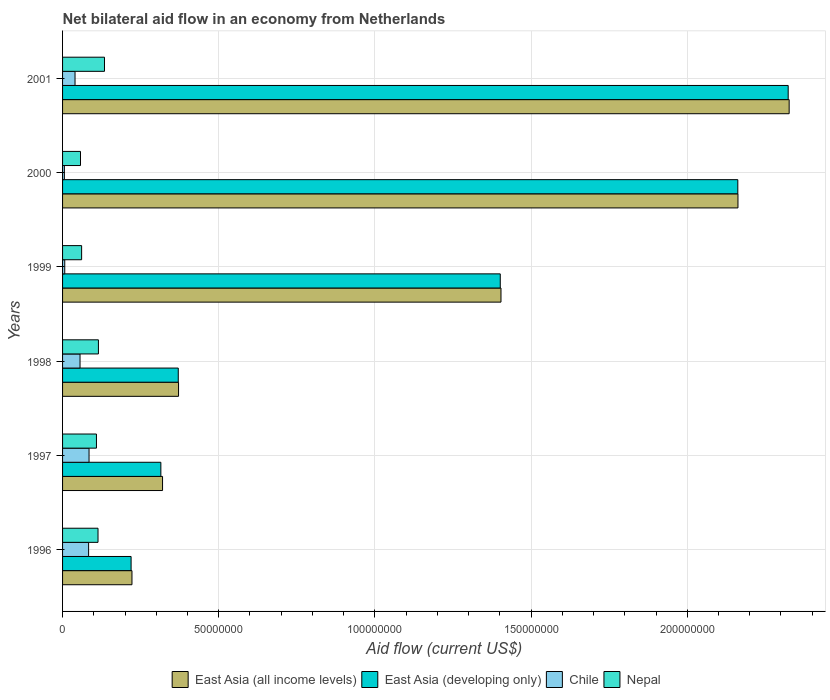How many different coloured bars are there?
Keep it short and to the point. 4. How many groups of bars are there?
Make the answer very short. 6. Are the number of bars per tick equal to the number of legend labels?
Make the answer very short. Yes. How many bars are there on the 3rd tick from the top?
Your response must be concise. 4. What is the label of the 3rd group of bars from the top?
Keep it short and to the point. 1999. What is the net bilateral aid flow in Nepal in 1999?
Provide a short and direct response. 6.10e+06. Across all years, what is the maximum net bilateral aid flow in East Asia (developing only)?
Make the answer very short. 2.32e+08. Across all years, what is the minimum net bilateral aid flow in Chile?
Provide a succinct answer. 5.80e+05. In which year was the net bilateral aid flow in East Asia (developing only) minimum?
Offer a very short reply. 1996. What is the total net bilateral aid flow in East Asia (all income levels) in the graph?
Your response must be concise. 6.81e+08. What is the difference between the net bilateral aid flow in East Asia (all income levels) in 1998 and that in 2001?
Your answer should be compact. -1.95e+08. What is the difference between the net bilateral aid flow in East Asia (all income levels) in 1997 and the net bilateral aid flow in Nepal in 1999?
Keep it short and to the point. 2.59e+07. What is the average net bilateral aid flow in Nepal per year?
Make the answer very short. 9.82e+06. In the year 2001, what is the difference between the net bilateral aid flow in Chile and net bilateral aid flow in East Asia (developing only)?
Your answer should be very brief. -2.28e+08. What is the ratio of the net bilateral aid flow in Nepal in 1996 to that in 2000?
Offer a very short reply. 1.98. Is the net bilateral aid flow in East Asia (developing only) in 1996 less than that in 1999?
Your response must be concise. Yes. Is the difference between the net bilateral aid flow in Chile in 1996 and 1999 greater than the difference between the net bilateral aid flow in East Asia (developing only) in 1996 and 1999?
Ensure brevity in your answer.  Yes. What is the difference between the highest and the lowest net bilateral aid flow in Nepal?
Your answer should be compact. 7.68e+06. In how many years, is the net bilateral aid flow in Chile greater than the average net bilateral aid flow in Chile taken over all years?
Your answer should be compact. 3. Is it the case that in every year, the sum of the net bilateral aid flow in Chile and net bilateral aid flow in Nepal is greater than the sum of net bilateral aid flow in East Asia (developing only) and net bilateral aid flow in East Asia (all income levels)?
Your answer should be very brief. No. What does the 3rd bar from the top in 2000 represents?
Your response must be concise. East Asia (developing only). What does the 2nd bar from the bottom in 1999 represents?
Make the answer very short. East Asia (developing only). Is it the case that in every year, the sum of the net bilateral aid flow in Chile and net bilateral aid flow in East Asia (developing only) is greater than the net bilateral aid flow in Nepal?
Your response must be concise. Yes. How many bars are there?
Offer a terse response. 24. How many legend labels are there?
Make the answer very short. 4. How are the legend labels stacked?
Provide a succinct answer. Horizontal. What is the title of the graph?
Offer a very short reply. Net bilateral aid flow in an economy from Netherlands. Does "Fiji" appear as one of the legend labels in the graph?
Give a very brief answer. No. What is the label or title of the X-axis?
Ensure brevity in your answer.  Aid flow (current US$). What is the label or title of the Y-axis?
Ensure brevity in your answer.  Years. What is the Aid flow (current US$) of East Asia (all income levels) in 1996?
Give a very brief answer. 2.22e+07. What is the Aid flow (current US$) of East Asia (developing only) in 1996?
Your answer should be very brief. 2.19e+07. What is the Aid flow (current US$) in Chile in 1996?
Make the answer very short. 8.34e+06. What is the Aid flow (current US$) in Nepal in 1996?
Your answer should be very brief. 1.14e+07. What is the Aid flow (current US$) in East Asia (all income levels) in 1997?
Your response must be concise. 3.20e+07. What is the Aid flow (current US$) of East Asia (developing only) in 1997?
Keep it short and to the point. 3.15e+07. What is the Aid flow (current US$) in Chile in 1997?
Your answer should be very brief. 8.48e+06. What is the Aid flow (current US$) of Nepal in 1997?
Offer a terse response. 1.08e+07. What is the Aid flow (current US$) of East Asia (all income levels) in 1998?
Keep it short and to the point. 3.71e+07. What is the Aid flow (current US$) of East Asia (developing only) in 1998?
Make the answer very short. 3.70e+07. What is the Aid flow (current US$) of Chile in 1998?
Offer a terse response. 5.59e+06. What is the Aid flow (current US$) in Nepal in 1998?
Offer a very short reply. 1.15e+07. What is the Aid flow (current US$) in East Asia (all income levels) in 1999?
Provide a short and direct response. 1.40e+08. What is the Aid flow (current US$) of East Asia (developing only) in 1999?
Provide a succinct answer. 1.40e+08. What is the Aid flow (current US$) in Nepal in 1999?
Give a very brief answer. 6.10e+06. What is the Aid flow (current US$) of East Asia (all income levels) in 2000?
Ensure brevity in your answer.  2.16e+08. What is the Aid flow (current US$) of East Asia (developing only) in 2000?
Ensure brevity in your answer.  2.16e+08. What is the Aid flow (current US$) in Chile in 2000?
Make the answer very short. 5.80e+05. What is the Aid flow (current US$) of Nepal in 2000?
Your answer should be very brief. 5.74e+06. What is the Aid flow (current US$) in East Asia (all income levels) in 2001?
Make the answer very short. 2.33e+08. What is the Aid flow (current US$) in East Asia (developing only) in 2001?
Provide a short and direct response. 2.32e+08. What is the Aid flow (current US$) in Chile in 2001?
Keep it short and to the point. 3.99e+06. What is the Aid flow (current US$) in Nepal in 2001?
Offer a very short reply. 1.34e+07. Across all years, what is the maximum Aid flow (current US$) in East Asia (all income levels)?
Your response must be concise. 2.33e+08. Across all years, what is the maximum Aid flow (current US$) in East Asia (developing only)?
Offer a terse response. 2.32e+08. Across all years, what is the maximum Aid flow (current US$) of Chile?
Provide a succinct answer. 8.48e+06. Across all years, what is the maximum Aid flow (current US$) of Nepal?
Keep it short and to the point. 1.34e+07. Across all years, what is the minimum Aid flow (current US$) of East Asia (all income levels)?
Give a very brief answer. 2.22e+07. Across all years, what is the minimum Aid flow (current US$) of East Asia (developing only)?
Your answer should be compact. 2.19e+07. Across all years, what is the minimum Aid flow (current US$) of Chile?
Offer a terse response. 5.80e+05. Across all years, what is the minimum Aid flow (current US$) in Nepal?
Give a very brief answer. 5.74e+06. What is the total Aid flow (current US$) in East Asia (all income levels) in the graph?
Offer a terse response. 6.81e+08. What is the total Aid flow (current US$) in East Asia (developing only) in the graph?
Give a very brief answer. 6.79e+08. What is the total Aid flow (current US$) of Chile in the graph?
Your answer should be compact. 2.77e+07. What is the total Aid flow (current US$) of Nepal in the graph?
Make the answer very short. 5.89e+07. What is the difference between the Aid flow (current US$) of East Asia (all income levels) in 1996 and that in 1997?
Make the answer very short. -9.79e+06. What is the difference between the Aid flow (current US$) in East Asia (developing only) in 1996 and that in 1997?
Keep it short and to the point. -9.53e+06. What is the difference between the Aid flow (current US$) in Chile in 1996 and that in 1997?
Offer a terse response. -1.40e+05. What is the difference between the Aid flow (current US$) of Nepal in 1996 and that in 1997?
Provide a short and direct response. 5.00e+05. What is the difference between the Aid flow (current US$) in East Asia (all income levels) in 1996 and that in 1998?
Provide a short and direct response. -1.49e+07. What is the difference between the Aid flow (current US$) in East Asia (developing only) in 1996 and that in 1998?
Your response must be concise. -1.51e+07. What is the difference between the Aid flow (current US$) of Chile in 1996 and that in 1998?
Your answer should be very brief. 2.75e+06. What is the difference between the Aid flow (current US$) in East Asia (all income levels) in 1996 and that in 1999?
Offer a very short reply. -1.18e+08. What is the difference between the Aid flow (current US$) of East Asia (developing only) in 1996 and that in 1999?
Provide a succinct answer. -1.18e+08. What is the difference between the Aid flow (current US$) of Chile in 1996 and that in 1999?
Provide a succinct answer. 7.64e+06. What is the difference between the Aid flow (current US$) of Nepal in 1996 and that in 1999?
Your answer should be very brief. 5.25e+06. What is the difference between the Aid flow (current US$) of East Asia (all income levels) in 1996 and that in 2000?
Give a very brief answer. -1.94e+08. What is the difference between the Aid flow (current US$) of East Asia (developing only) in 1996 and that in 2000?
Offer a terse response. -1.94e+08. What is the difference between the Aid flow (current US$) in Chile in 1996 and that in 2000?
Make the answer very short. 7.76e+06. What is the difference between the Aid flow (current US$) of Nepal in 1996 and that in 2000?
Give a very brief answer. 5.61e+06. What is the difference between the Aid flow (current US$) of East Asia (all income levels) in 1996 and that in 2001?
Your response must be concise. -2.10e+08. What is the difference between the Aid flow (current US$) of East Asia (developing only) in 1996 and that in 2001?
Offer a terse response. -2.10e+08. What is the difference between the Aid flow (current US$) of Chile in 1996 and that in 2001?
Make the answer very short. 4.35e+06. What is the difference between the Aid flow (current US$) in Nepal in 1996 and that in 2001?
Offer a terse response. -2.07e+06. What is the difference between the Aid flow (current US$) of East Asia (all income levels) in 1997 and that in 1998?
Your answer should be very brief. -5.12e+06. What is the difference between the Aid flow (current US$) of East Asia (developing only) in 1997 and that in 1998?
Your response must be concise. -5.57e+06. What is the difference between the Aid flow (current US$) in Chile in 1997 and that in 1998?
Keep it short and to the point. 2.89e+06. What is the difference between the Aid flow (current US$) in Nepal in 1997 and that in 1998?
Make the answer very short. -6.30e+05. What is the difference between the Aid flow (current US$) of East Asia (all income levels) in 1997 and that in 1999?
Ensure brevity in your answer.  -1.08e+08. What is the difference between the Aid flow (current US$) of East Asia (developing only) in 1997 and that in 1999?
Your answer should be compact. -1.09e+08. What is the difference between the Aid flow (current US$) in Chile in 1997 and that in 1999?
Provide a succinct answer. 7.78e+06. What is the difference between the Aid flow (current US$) in Nepal in 1997 and that in 1999?
Give a very brief answer. 4.75e+06. What is the difference between the Aid flow (current US$) of East Asia (all income levels) in 1997 and that in 2000?
Your answer should be very brief. -1.84e+08. What is the difference between the Aid flow (current US$) of East Asia (developing only) in 1997 and that in 2000?
Give a very brief answer. -1.85e+08. What is the difference between the Aid flow (current US$) of Chile in 1997 and that in 2000?
Give a very brief answer. 7.90e+06. What is the difference between the Aid flow (current US$) of Nepal in 1997 and that in 2000?
Keep it short and to the point. 5.11e+06. What is the difference between the Aid flow (current US$) of East Asia (all income levels) in 1997 and that in 2001?
Your answer should be very brief. -2.01e+08. What is the difference between the Aid flow (current US$) of East Asia (developing only) in 1997 and that in 2001?
Ensure brevity in your answer.  -2.01e+08. What is the difference between the Aid flow (current US$) of Chile in 1997 and that in 2001?
Ensure brevity in your answer.  4.49e+06. What is the difference between the Aid flow (current US$) in Nepal in 1997 and that in 2001?
Your response must be concise. -2.57e+06. What is the difference between the Aid flow (current US$) of East Asia (all income levels) in 1998 and that in 1999?
Provide a succinct answer. -1.03e+08. What is the difference between the Aid flow (current US$) of East Asia (developing only) in 1998 and that in 1999?
Your answer should be very brief. -1.03e+08. What is the difference between the Aid flow (current US$) of Chile in 1998 and that in 1999?
Offer a very short reply. 4.89e+06. What is the difference between the Aid flow (current US$) in Nepal in 1998 and that in 1999?
Provide a succinct answer. 5.38e+06. What is the difference between the Aid flow (current US$) of East Asia (all income levels) in 1998 and that in 2000?
Your answer should be compact. -1.79e+08. What is the difference between the Aid flow (current US$) of East Asia (developing only) in 1998 and that in 2000?
Your response must be concise. -1.79e+08. What is the difference between the Aid flow (current US$) in Chile in 1998 and that in 2000?
Make the answer very short. 5.01e+06. What is the difference between the Aid flow (current US$) of Nepal in 1998 and that in 2000?
Your answer should be very brief. 5.74e+06. What is the difference between the Aid flow (current US$) in East Asia (all income levels) in 1998 and that in 2001?
Offer a terse response. -1.95e+08. What is the difference between the Aid flow (current US$) of East Asia (developing only) in 1998 and that in 2001?
Offer a very short reply. -1.95e+08. What is the difference between the Aid flow (current US$) of Chile in 1998 and that in 2001?
Offer a terse response. 1.60e+06. What is the difference between the Aid flow (current US$) of Nepal in 1998 and that in 2001?
Provide a short and direct response. -1.94e+06. What is the difference between the Aid flow (current US$) of East Asia (all income levels) in 1999 and that in 2000?
Ensure brevity in your answer.  -7.59e+07. What is the difference between the Aid flow (current US$) in East Asia (developing only) in 1999 and that in 2000?
Offer a terse response. -7.60e+07. What is the difference between the Aid flow (current US$) in Nepal in 1999 and that in 2000?
Ensure brevity in your answer.  3.60e+05. What is the difference between the Aid flow (current US$) in East Asia (all income levels) in 1999 and that in 2001?
Provide a succinct answer. -9.23e+07. What is the difference between the Aid flow (current US$) in East Asia (developing only) in 1999 and that in 2001?
Offer a terse response. -9.22e+07. What is the difference between the Aid flow (current US$) of Chile in 1999 and that in 2001?
Your response must be concise. -3.29e+06. What is the difference between the Aid flow (current US$) in Nepal in 1999 and that in 2001?
Offer a terse response. -7.32e+06. What is the difference between the Aid flow (current US$) in East Asia (all income levels) in 2000 and that in 2001?
Ensure brevity in your answer.  -1.64e+07. What is the difference between the Aid flow (current US$) of East Asia (developing only) in 2000 and that in 2001?
Make the answer very short. -1.61e+07. What is the difference between the Aid flow (current US$) in Chile in 2000 and that in 2001?
Provide a short and direct response. -3.41e+06. What is the difference between the Aid flow (current US$) of Nepal in 2000 and that in 2001?
Your answer should be very brief. -7.68e+06. What is the difference between the Aid flow (current US$) in East Asia (all income levels) in 1996 and the Aid flow (current US$) in East Asia (developing only) in 1997?
Your response must be concise. -9.25e+06. What is the difference between the Aid flow (current US$) of East Asia (all income levels) in 1996 and the Aid flow (current US$) of Chile in 1997?
Your response must be concise. 1.37e+07. What is the difference between the Aid flow (current US$) of East Asia (all income levels) in 1996 and the Aid flow (current US$) of Nepal in 1997?
Offer a very short reply. 1.14e+07. What is the difference between the Aid flow (current US$) of East Asia (developing only) in 1996 and the Aid flow (current US$) of Chile in 1997?
Give a very brief answer. 1.35e+07. What is the difference between the Aid flow (current US$) in East Asia (developing only) in 1996 and the Aid flow (current US$) in Nepal in 1997?
Provide a succinct answer. 1.11e+07. What is the difference between the Aid flow (current US$) of Chile in 1996 and the Aid flow (current US$) of Nepal in 1997?
Ensure brevity in your answer.  -2.51e+06. What is the difference between the Aid flow (current US$) in East Asia (all income levels) in 1996 and the Aid flow (current US$) in East Asia (developing only) in 1998?
Keep it short and to the point. -1.48e+07. What is the difference between the Aid flow (current US$) in East Asia (all income levels) in 1996 and the Aid flow (current US$) in Chile in 1998?
Give a very brief answer. 1.66e+07. What is the difference between the Aid flow (current US$) in East Asia (all income levels) in 1996 and the Aid flow (current US$) in Nepal in 1998?
Make the answer very short. 1.07e+07. What is the difference between the Aid flow (current US$) of East Asia (developing only) in 1996 and the Aid flow (current US$) of Chile in 1998?
Keep it short and to the point. 1.64e+07. What is the difference between the Aid flow (current US$) in East Asia (developing only) in 1996 and the Aid flow (current US$) in Nepal in 1998?
Provide a short and direct response. 1.05e+07. What is the difference between the Aid flow (current US$) of Chile in 1996 and the Aid flow (current US$) of Nepal in 1998?
Offer a terse response. -3.14e+06. What is the difference between the Aid flow (current US$) in East Asia (all income levels) in 1996 and the Aid flow (current US$) in East Asia (developing only) in 1999?
Your response must be concise. -1.18e+08. What is the difference between the Aid flow (current US$) of East Asia (all income levels) in 1996 and the Aid flow (current US$) of Chile in 1999?
Your response must be concise. 2.15e+07. What is the difference between the Aid flow (current US$) of East Asia (all income levels) in 1996 and the Aid flow (current US$) of Nepal in 1999?
Ensure brevity in your answer.  1.61e+07. What is the difference between the Aid flow (current US$) in East Asia (developing only) in 1996 and the Aid flow (current US$) in Chile in 1999?
Your answer should be compact. 2.12e+07. What is the difference between the Aid flow (current US$) in East Asia (developing only) in 1996 and the Aid flow (current US$) in Nepal in 1999?
Offer a terse response. 1.58e+07. What is the difference between the Aid flow (current US$) in Chile in 1996 and the Aid flow (current US$) in Nepal in 1999?
Give a very brief answer. 2.24e+06. What is the difference between the Aid flow (current US$) of East Asia (all income levels) in 1996 and the Aid flow (current US$) of East Asia (developing only) in 2000?
Your response must be concise. -1.94e+08. What is the difference between the Aid flow (current US$) in East Asia (all income levels) in 1996 and the Aid flow (current US$) in Chile in 2000?
Provide a succinct answer. 2.16e+07. What is the difference between the Aid flow (current US$) of East Asia (all income levels) in 1996 and the Aid flow (current US$) of Nepal in 2000?
Your answer should be very brief. 1.65e+07. What is the difference between the Aid flow (current US$) in East Asia (developing only) in 1996 and the Aid flow (current US$) in Chile in 2000?
Give a very brief answer. 2.14e+07. What is the difference between the Aid flow (current US$) of East Asia (developing only) in 1996 and the Aid flow (current US$) of Nepal in 2000?
Keep it short and to the point. 1.62e+07. What is the difference between the Aid flow (current US$) in Chile in 1996 and the Aid flow (current US$) in Nepal in 2000?
Your answer should be very brief. 2.60e+06. What is the difference between the Aid flow (current US$) of East Asia (all income levels) in 1996 and the Aid flow (current US$) of East Asia (developing only) in 2001?
Your answer should be very brief. -2.10e+08. What is the difference between the Aid flow (current US$) in East Asia (all income levels) in 1996 and the Aid flow (current US$) in Chile in 2001?
Make the answer very short. 1.82e+07. What is the difference between the Aid flow (current US$) of East Asia (all income levels) in 1996 and the Aid flow (current US$) of Nepal in 2001?
Make the answer very short. 8.80e+06. What is the difference between the Aid flow (current US$) of East Asia (developing only) in 1996 and the Aid flow (current US$) of Chile in 2001?
Your answer should be compact. 1.80e+07. What is the difference between the Aid flow (current US$) in East Asia (developing only) in 1996 and the Aid flow (current US$) in Nepal in 2001?
Your response must be concise. 8.52e+06. What is the difference between the Aid flow (current US$) in Chile in 1996 and the Aid flow (current US$) in Nepal in 2001?
Your answer should be compact. -5.08e+06. What is the difference between the Aid flow (current US$) of East Asia (all income levels) in 1997 and the Aid flow (current US$) of East Asia (developing only) in 1998?
Provide a succinct answer. -5.03e+06. What is the difference between the Aid flow (current US$) of East Asia (all income levels) in 1997 and the Aid flow (current US$) of Chile in 1998?
Your response must be concise. 2.64e+07. What is the difference between the Aid flow (current US$) in East Asia (all income levels) in 1997 and the Aid flow (current US$) in Nepal in 1998?
Your answer should be compact. 2.05e+07. What is the difference between the Aid flow (current US$) in East Asia (developing only) in 1997 and the Aid flow (current US$) in Chile in 1998?
Offer a terse response. 2.59e+07. What is the difference between the Aid flow (current US$) of East Asia (developing only) in 1997 and the Aid flow (current US$) of Nepal in 1998?
Offer a very short reply. 2.00e+07. What is the difference between the Aid flow (current US$) in Chile in 1997 and the Aid flow (current US$) in Nepal in 1998?
Offer a very short reply. -3.00e+06. What is the difference between the Aid flow (current US$) in East Asia (all income levels) in 1997 and the Aid flow (current US$) in East Asia (developing only) in 1999?
Your answer should be very brief. -1.08e+08. What is the difference between the Aid flow (current US$) in East Asia (all income levels) in 1997 and the Aid flow (current US$) in Chile in 1999?
Give a very brief answer. 3.13e+07. What is the difference between the Aid flow (current US$) in East Asia (all income levels) in 1997 and the Aid flow (current US$) in Nepal in 1999?
Offer a very short reply. 2.59e+07. What is the difference between the Aid flow (current US$) in East Asia (developing only) in 1997 and the Aid flow (current US$) in Chile in 1999?
Provide a succinct answer. 3.08e+07. What is the difference between the Aid flow (current US$) in East Asia (developing only) in 1997 and the Aid flow (current US$) in Nepal in 1999?
Provide a short and direct response. 2.54e+07. What is the difference between the Aid flow (current US$) in Chile in 1997 and the Aid flow (current US$) in Nepal in 1999?
Offer a terse response. 2.38e+06. What is the difference between the Aid flow (current US$) in East Asia (all income levels) in 1997 and the Aid flow (current US$) in East Asia (developing only) in 2000?
Your answer should be very brief. -1.84e+08. What is the difference between the Aid flow (current US$) of East Asia (all income levels) in 1997 and the Aid flow (current US$) of Chile in 2000?
Provide a short and direct response. 3.14e+07. What is the difference between the Aid flow (current US$) in East Asia (all income levels) in 1997 and the Aid flow (current US$) in Nepal in 2000?
Provide a succinct answer. 2.63e+07. What is the difference between the Aid flow (current US$) of East Asia (developing only) in 1997 and the Aid flow (current US$) of Chile in 2000?
Provide a succinct answer. 3.09e+07. What is the difference between the Aid flow (current US$) of East Asia (developing only) in 1997 and the Aid flow (current US$) of Nepal in 2000?
Make the answer very short. 2.57e+07. What is the difference between the Aid flow (current US$) of Chile in 1997 and the Aid flow (current US$) of Nepal in 2000?
Ensure brevity in your answer.  2.74e+06. What is the difference between the Aid flow (current US$) of East Asia (all income levels) in 1997 and the Aid flow (current US$) of East Asia (developing only) in 2001?
Provide a succinct answer. -2.00e+08. What is the difference between the Aid flow (current US$) in East Asia (all income levels) in 1997 and the Aid flow (current US$) in Chile in 2001?
Keep it short and to the point. 2.80e+07. What is the difference between the Aid flow (current US$) of East Asia (all income levels) in 1997 and the Aid flow (current US$) of Nepal in 2001?
Your response must be concise. 1.86e+07. What is the difference between the Aid flow (current US$) of East Asia (developing only) in 1997 and the Aid flow (current US$) of Chile in 2001?
Your response must be concise. 2.75e+07. What is the difference between the Aid flow (current US$) of East Asia (developing only) in 1997 and the Aid flow (current US$) of Nepal in 2001?
Offer a terse response. 1.80e+07. What is the difference between the Aid flow (current US$) of Chile in 1997 and the Aid flow (current US$) of Nepal in 2001?
Your answer should be compact. -4.94e+06. What is the difference between the Aid flow (current US$) in East Asia (all income levels) in 1998 and the Aid flow (current US$) in East Asia (developing only) in 1999?
Your answer should be very brief. -1.03e+08. What is the difference between the Aid flow (current US$) of East Asia (all income levels) in 1998 and the Aid flow (current US$) of Chile in 1999?
Your response must be concise. 3.64e+07. What is the difference between the Aid flow (current US$) in East Asia (all income levels) in 1998 and the Aid flow (current US$) in Nepal in 1999?
Offer a very short reply. 3.10e+07. What is the difference between the Aid flow (current US$) of East Asia (developing only) in 1998 and the Aid flow (current US$) of Chile in 1999?
Provide a short and direct response. 3.63e+07. What is the difference between the Aid flow (current US$) in East Asia (developing only) in 1998 and the Aid flow (current US$) in Nepal in 1999?
Your response must be concise. 3.09e+07. What is the difference between the Aid flow (current US$) of Chile in 1998 and the Aid flow (current US$) of Nepal in 1999?
Provide a short and direct response. -5.10e+05. What is the difference between the Aid flow (current US$) in East Asia (all income levels) in 1998 and the Aid flow (current US$) in East Asia (developing only) in 2000?
Give a very brief answer. -1.79e+08. What is the difference between the Aid flow (current US$) of East Asia (all income levels) in 1998 and the Aid flow (current US$) of Chile in 2000?
Keep it short and to the point. 3.66e+07. What is the difference between the Aid flow (current US$) in East Asia (all income levels) in 1998 and the Aid flow (current US$) in Nepal in 2000?
Provide a succinct answer. 3.14e+07. What is the difference between the Aid flow (current US$) of East Asia (developing only) in 1998 and the Aid flow (current US$) of Chile in 2000?
Offer a terse response. 3.65e+07. What is the difference between the Aid flow (current US$) of East Asia (developing only) in 1998 and the Aid flow (current US$) of Nepal in 2000?
Ensure brevity in your answer.  3.13e+07. What is the difference between the Aid flow (current US$) in Chile in 1998 and the Aid flow (current US$) in Nepal in 2000?
Your response must be concise. -1.50e+05. What is the difference between the Aid flow (current US$) in East Asia (all income levels) in 1998 and the Aid flow (current US$) in East Asia (developing only) in 2001?
Offer a terse response. -1.95e+08. What is the difference between the Aid flow (current US$) in East Asia (all income levels) in 1998 and the Aid flow (current US$) in Chile in 2001?
Make the answer very short. 3.31e+07. What is the difference between the Aid flow (current US$) of East Asia (all income levels) in 1998 and the Aid flow (current US$) of Nepal in 2001?
Provide a succinct answer. 2.37e+07. What is the difference between the Aid flow (current US$) of East Asia (developing only) in 1998 and the Aid flow (current US$) of Chile in 2001?
Make the answer very short. 3.30e+07. What is the difference between the Aid flow (current US$) in East Asia (developing only) in 1998 and the Aid flow (current US$) in Nepal in 2001?
Offer a terse response. 2.36e+07. What is the difference between the Aid flow (current US$) of Chile in 1998 and the Aid flow (current US$) of Nepal in 2001?
Your response must be concise. -7.83e+06. What is the difference between the Aid flow (current US$) in East Asia (all income levels) in 1999 and the Aid flow (current US$) in East Asia (developing only) in 2000?
Offer a terse response. -7.58e+07. What is the difference between the Aid flow (current US$) in East Asia (all income levels) in 1999 and the Aid flow (current US$) in Chile in 2000?
Make the answer very short. 1.40e+08. What is the difference between the Aid flow (current US$) of East Asia (all income levels) in 1999 and the Aid flow (current US$) of Nepal in 2000?
Offer a terse response. 1.35e+08. What is the difference between the Aid flow (current US$) in East Asia (developing only) in 1999 and the Aid flow (current US$) in Chile in 2000?
Ensure brevity in your answer.  1.40e+08. What is the difference between the Aid flow (current US$) of East Asia (developing only) in 1999 and the Aid flow (current US$) of Nepal in 2000?
Your response must be concise. 1.34e+08. What is the difference between the Aid flow (current US$) in Chile in 1999 and the Aid flow (current US$) in Nepal in 2000?
Provide a succinct answer. -5.04e+06. What is the difference between the Aid flow (current US$) of East Asia (all income levels) in 1999 and the Aid flow (current US$) of East Asia (developing only) in 2001?
Your response must be concise. -9.20e+07. What is the difference between the Aid flow (current US$) in East Asia (all income levels) in 1999 and the Aid flow (current US$) in Chile in 2001?
Offer a very short reply. 1.36e+08. What is the difference between the Aid flow (current US$) of East Asia (all income levels) in 1999 and the Aid flow (current US$) of Nepal in 2001?
Your answer should be very brief. 1.27e+08. What is the difference between the Aid flow (current US$) in East Asia (developing only) in 1999 and the Aid flow (current US$) in Chile in 2001?
Offer a terse response. 1.36e+08. What is the difference between the Aid flow (current US$) of East Asia (developing only) in 1999 and the Aid flow (current US$) of Nepal in 2001?
Your answer should be compact. 1.27e+08. What is the difference between the Aid flow (current US$) in Chile in 1999 and the Aid flow (current US$) in Nepal in 2001?
Your response must be concise. -1.27e+07. What is the difference between the Aid flow (current US$) in East Asia (all income levels) in 2000 and the Aid flow (current US$) in East Asia (developing only) in 2001?
Offer a terse response. -1.61e+07. What is the difference between the Aid flow (current US$) in East Asia (all income levels) in 2000 and the Aid flow (current US$) in Chile in 2001?
Make the answer very short. 2.12e+08. What is the difference between the Aid flow (current US$) of East Asia (all income levels) in 2000 and the Aid flow (current US$) of Nepal in 2001?
Your answer should be compact. 2.03e+08. What is the difference between the Aid flow (current US$) of East Asia (developing only) in 2000 and the Aid flow (current US$) of Chile in 2001?
Give a very brief answer. 2.12e+08. What is the difference between the Aid flow (current US$) in East Asia (developing only) in 2000 and the Aid flow (current US$) in Nepal in 2001?
Ensure brevity in your answer.  2.03e+08. What is the difference between the Aid flow (current US$) in Chile in 2000 and the Aid flow (current US$) in Nepal in 2001?
Your answer should be compact. -1.28e+07. What is the average Aid flow (current US$) of East Asia (all income levels) per year?
Make the answer very short. 1.13e+08. What is the average Aid flow (current US$) in East Asia (developing only) per year?
Keep it short and to the point. 1.13e+08. What is the average Aid flow (current US$) in Chile per year?
Provide a short and direct response. 4.61e+06. What is the average Aid flow (current US$) in Nepal per year?
Your response must be concise. 9.82e+06. In the year 1996, what is the difference between the Aid flow (current US$) in East Asia (all income levels) and Aid flow (current US$) in Chile?
Give a very brief answer. 1.39e+07. In the year 1996, what is the difference between the Aid flow (current US$) of East Asia (all income levels) and Aid flow (current US$) of Nepal?
Offer a very short reply. 1.09e+07. In the year 1996, what is the difference between the Aid flow (current US$) in East Asia (developing only) and Aid flow (current US$) in Chile?
Keep it short and to the point. 1.36e+07. In the year 1996, what is the difference between the Aid flow (current US$) of East Asia (developing only) and Aid flow (current US$) of Nepal?
Give a very brief answer. 1.06e+07. In the year 1996, what is the difference between the Aid flow (current US$) in Chile and Aid flow (current US$) in Nepal?
Offer a very short reply. -3.01e+06. In the year 1997, what is the difference between the Aid flow (current US$) in East Asia (all income levels) and Aid flow (current US$) in East Asia (developing only)?
Offer a terse response. 5.40e+05. In the year 1997, what is the difference between the Aid flow (current US$) in East Asia (all income levels) and Aid flow (current US$) in Chile?
Your answer should be compact. 2.35e+07. In the year 1997, what is the difference between the Aid flow (current US$) in East Asia (all income levels) and Aid flow (current US$) in Nepal?
Offer a very short reply. 2.12e+07. In the year 1997, what is the difference between the Aid flow (current US$) in East Asia (developing only) and Aid flow (current US$) in Chile?
Provide a short and direct response. 2.30e+07. In the year 1997, what is the difference between the Aid flow (current US$) of East Asia (developing only) and Aid flow (current US$) of Nepal?
Ensure brevity in your answer.  2.06e+07. In the year 1997, what is the difference between the Aid flow (current US$) in Chile and Aid flow (current US$) in Nepal?
Your answer should be very brief. -2.37e+06. In the year 1998, what is the difference between the Aid flow (current US$) in East Asia (all income levels) and Aid flow (current US$) in East Asia (developing only)?
Your answer should be compact. 9.00e+04. In the year 1998, what is the difference between the Aid flow (current US$) of East Asia (all income levels) and Aid flow (current US$) of Chile?
Ensure brevity in your answer.  3.15e+07. In the year 1998, what is the difference between the Aid flow (current US$) of East Asia (all income levels) and Aid flow (current US$) of Nepal?
Provide a succinct answer. 2.56e+07. In the year 1998, what is the difference between the Aid flow (current US$) of East Asia (developing only) and Aid flow (current US$) of Chile?
Your answer should be compact. 3.14e+07. In the year 1998, what is the difference between the Aid flow (current US$) in East Asia (developing only) and Aid flow (current US$) in Nepal?
Your response must be concise. 2.56e+07. In the year 1998, what is the difference between the Aid flow (current US$) in Chile and Aid flow (current US$) in Nepal?
Your response must be concise. -5.89e+06. In the year 1999, what is the difference between the Aid flow (current US$) in East Asia (all income levels) and Aid flow (current US$) in Chile?
Your answer should be compact. 1.40e+08. In the year 1999, what is the difference between the Aid flow (current US$) in East Asia (all income levels) and Aid flow (current US$) in Nepal?
Your answer should be compact. 1.34e+08. In the year 1999, what is the difference between the Aid flow (current US$) of East Asia (developing only) and Aid flow (current US$) of Chile?
Make the answer very short. 1.39e+08. In the year 1999, what is the difference between the Aid flow (current US$) in East Asia (developing only) and Aid flow (current US$) in Nepal?
Give a very brief answer. 1.34e+08. In the year 1999, what is the difference between the Aid flow (current US$) of Chile and Aid flow (current US$) of Nepal?
Provide a short and direct response. -5.40e+06. In the year 2000, what is the difference between the Aid flow (current US$) of East Asia (all income levels) and Aid flow (current US$) of East Asia (developing only)?
Make the answer very short. 5.00e+04. In the year 2000, what is the difference between the Aid flow (current US$) in East Asia (all income levels) and Aid flow (current US$) in Chile?
Offer a terse response. 2.16e+08. In the year 2000, what is the difference between the Aid flow (current US$) of East Asia (all income levels) and Aid flow (current US$) of Nepal?
Your response must be concise. 2.10e+08. In the year 2000, what is the difference between the Aid flow (current US$) of East Asia (developing only) and Aid flow (current US$) of Chile?
Give a very brief answer. 2.16e+08. In the year 2000, what is the difference between the Aid flow (current US$) of East Asia (developing only) and Aid flow (current US$) of Nepal?
Your response must be concise. 2.10e+08. In the year 2000, what is the difference between the Aid flow (current US$) of Chile and Aid flow (current US$) of Nepal?
Offer a terse response. -5.16e+06. In the year 2001, what is the difference between the Aid flow (current US$) of East Asia (all income levels) and Aid flow (current US$) of East Asia (developing only)?
Your answer should be very brief. 3.10e+05. In the year 2001, what is the difference between the Aid flow (current US$) in East Asia (all income levels) and Aid flow (current US$) in Chile?
Keep it short and to the point. 2.29e+08. In the year 2001, what is the difference between the Aid flow (current US$) in East Asia (all income levels) and Aid flow (current US$) in Nepal?
Offer a terse response. 2.19e+08. In the year 2001, what is the difference between the Aid flow (current US$) of East Asia (developing only) and Aid flow (current US$) of Chile?
Give a very brief answer. 2.28e+08. In the year 2001, what is the difference between the Aid flow (current US$) in East Asia (developing only) and Aid flow (current US$) in Nepal?
Offer a terse response. 2.19e+08. In the year 2001, what is the difference between the Aid flow (current US$) of Chile and Aid flow (current US$) of Nepal?
Offer a terse response. -9.43e+06. What is the ratio of the Aid flow (current US$) in East Asia (all income levels) in 1996 to that in 1997?
Your answer should be compact. 0.69. What is the ratio of the Aid flow (current US$) of East Asia (developing only) in 1996 to that in 1997?
Offer a terse response. 0.7. What is the ratio of the Aid flow (current US$) of Chile in 1996 to that in 1997?
Give a very brief answer. 0.98. What is the ratio of the Aid flow (current US$) of Nepal in 1996 to that in 1997?
Your answer should be very brief. 1.05. What is the ratio of the Aid flow (current US$) of East Asia (all income levels) in 1996 to that in 1998?
Keep it short and to the point. 0.6. What is the ratio of the Aid flow (current US$) in East Asia (developing only) in 1996 to that in 1998?
Keep it short and to the point. 0.59. What is the ratio of the Aid flow (current US$) in Chile in 1996 to that in 1998?
Give a very brief answer. 1.49. What is the ratio of the Aid flow (current US$) of Nepal in 1996 to that in 1998?
Your response must be concise. 0.99. What is the ratio of the Aid flow (current US$) in East Asia (all income levels) in 1996 to that in 1999?
Provide a succinct answer. 0.16. What is the ratio of the Aid flow (current US$) in East Asia (developing only) in 1996 to that in 1999?
Give a very brief answer. 0.16. What is the ratio of the Aid flow (current US$) in Chile in 1996 to that in 1999?
Keep it short and to the point. 11.91. What is the ratio of the Aid flow (current US$) in Nepal in 1996 to that in 1999?
Provide a succinct answer. 1.86. What is the ratio of the Aid flow (current US$) of East Asia (all income levels) in 1996 to that in 2000?
Offer a very short reply. 0.1. What is the ratio of the Aid flow (current US$) in East Asia (developing only) in 1996 to that in 2000?
Give a very brief answer. 0.1. What is the ratio of the Aid flow (current US$) of Chile in 1996 to that in 2000?
Provide a succinct answer. 14.38. What is the ratio of the Aid flow (current US$) of Nepal in 1996 to that in 2000?
Keep it short and to the point. 1.98. What is the ratio of the Aid flow (current US$) of East Asia (all income levels) in 1996 to that in 2001?
Keep it short and to the point. 0.1. What is the ratio of the Aid flow (current US$) in East Asia (developing only) in 1996 to that in 2001?
Provide a succinct answer. 0.09. What is the ratio of the Aid flow (current US$) in Chile in 1996 to that in 2001?
Make the answer very short. 2.09. What is the ratio of the Aid flow (current US$) of Nepal in 1996 to that in 2001?
Offer a terse response. 0.85. What is the ratio of the Aid flow (current US$) of East Asia (all income levels) in 1997 to that in 1998?
Offer a very short reply. 0.86. What is the ratio of the Aid flow (current US$) in East Asia (developing only) in 1997 to that in 1998?
Provide a succinct answer. 0.85. What is the ratio of the Aid flow (current US$) in Chile in 1997 to that in 1998?
Offer a terse response. 1.52. What is the ratio of the Aid flow (current US$) in Nepal in 1997 to that in 1998?
Your answer should be very brief. 0.95. What is the ratio of the Aid flow (current US$) of East Asia (all income levels) in 1997 to that in 1999?
Your answer should be compact. 0.23. What is the ratio of the Aid flow (current US$) in East Asia (developing only) in 1997 to that in 1999?
Provide a succinct answer. 0.22. What is the ratio of the Aid flow (current US$) in Chile in 1997 to that in 1999?
Provide a succinct answer. 12.11. What is the ratio of the Aid flow (current US$) of Nepal in 1997 to that in 1999?
Offer a terse response. 1.78. What is the ratio of the Aid flow (current US$) in East Asia (all income levels) in 1997 to that in 2000?
Ensure brevity in your answer.  0.15. What is the ratio of the Aid flow (current US$) in East Asia (developing only) in 1997 to that in 2000?
Provide a succinct answer. 0.15. What is the ratio of the Aid flow (current US$) in Chile in 1997 to that in 2000?
Your response must be concise. 14.62. What is the ratio of the Aid flow (current US$) of Nepal in 1997 to that in 2000?
Make the answer very short. 1.89. What is the ratio of the Aid flow (current US$) in East Asia (all income levels) in 1997 to that in 2001?
Give a very brief answer. 0.14. What is the ratio of the Aid flow (current US$) of East Asia (developing only) in 1997 to that in 2001?
Ensure brevity in your answer.  0.14. What is the ratio of the Aid flow (current US$) in Chile in 1997 to that in 2001?
Your response must be concise. 2.13. What is the ratio of the Aid flow (current US$) of Nepal in 1997 to that in 2001?
Offer a very short reply. 0.81. What is the ratio of the Aid flow (current US$) of East Asia (all income levels) in 1998 to that in 1999?
Offer a very short reply. 0.26. What is the ratio of the Aid flow (current US$) of East Asia (developing only) in 1998 to that in 1999?
Your answer should be very brief. 0.26. What is the ratio of the Aid flow (current US$) of Chile in 1998 to that in 1999?
Your answer should be very brief. 7.99. What is the ratio of the Aid flow (current US$) in Nepal in 1998 to that in 1999?
Ensure brevity in your answer.  1.88. What is the ratio of the Aid flow (current US$) of East Asia (all income levels) in 1998 to that in 2000?
Make the answer very short. 0.17. What is the ratio of the Aid flow (current US$) in East Asia (developing only) in 1998 to that in 2000?
Your response must be concise. 0.17. What is the ratio of the Aid flow (current US$) in Chile in 1998 to that in 2000?
Your answer should be compact. 9.64. What is the ratio of the Aid flow (current US$) of East Asia (all income levels) in 1998 to that in 2001?
Provide a succinct answer. 0.16. What is the ratio of the Aid flow (current US$) in East Asia (developing only) in 1998 to that in 2001?
Make the answer very short. 0.16. What is the ratio of the Aid flow (current US$) of Chile in 1998 to that in 2001?
Keep it short and to the point. 1.4. What is the ratio of the Aid flow (current US$) in Nepal in 1998 to that in 2001?
Your response must be concise. 0.86. What is the ratio of the Aid flow (current US$) in East Asia (all income levels) in 1999 to that in 2000?
Your answer should be compact. 0.65. What is the ratio of the Aid flow (current US$) of East Asia (developing only) in 1999 to that in 2000?
Your response must be concise. 0.65. What is the ratio of the Aid flow (current US$) in Chile in 1999 to that in 2000?
Give a very brief answer. 1.21. What is the ratio of the Aid flow (current US$) in Nepal in 1999 to that in 2000?
Make the answer very short. 1.06. What is the ratio of the Aid flow (current US$) of East Asia (all income levels) in 1999 to that in 2001?
Offer a terse response. 0.6. What is the ratio of the Aid flow (current US$) in East Asia (developing only) in 1999 to that in 2001?
Provide a short and direct response. 0.6. What is the ratio of the Aid flow (current US$) of Chile in 1999 to that in 2001?
Ensure brevity in your answer.  0.18. What is the ratio of the Aid flow (current US$) of Nepal in 1999 to that in 2001?
Make the answer very short. 0.45. What is the ratio of the Aid flow (current US$) in East Asia (all income levels) in 2000 to that in 2001?
Provide a short and direct response. 0.93. What is the ratio of the Aid flow (current US$) in East Asia (developing only) in 2000 to that in 2001?
Your answer should be very brief. 0.93. What is the ratio of the Aid flow (current US$) of Chile in 2000 to that in 2001?
Offer a terse response. 0.15. What is the ratio of the Aid flow (current US$) of Nepal in 2000 to that in 2001?
Offer a very short reply. 0.43. What is the difference between the highest and the second highest Aid flow (current US$) of East Asia (all income levels)?
Your response must be concise. 1.64e+07. What is the difference between the highest and the second highest Aid flow (current US$) of East Asia (developing only)?
Give a very brief answer. 1.61e+07. What is the difference between the highest and the second highest Aid flow (current US$) in Nepal?
Your answer should be compact. 1.94e+06. What is the difference between the highest and the lowest Aid flow (current US$) in East Asia (all income levels)?
Make the answer very short. 2.10e+08. What is the difference between the highest and the lowest Aid flow (current US$) in East Asia (developing only)?
Offer a very short reply. 2.10e+08. What is the difference between the highest and the lowest Aid flow (current US$) of Chile?
Make the answer very short. 7.90e+06. What is the difference between the highest and the lowest Aid flow (current US$) in Nepal?
Make the answer very short. 7.68e+06. 